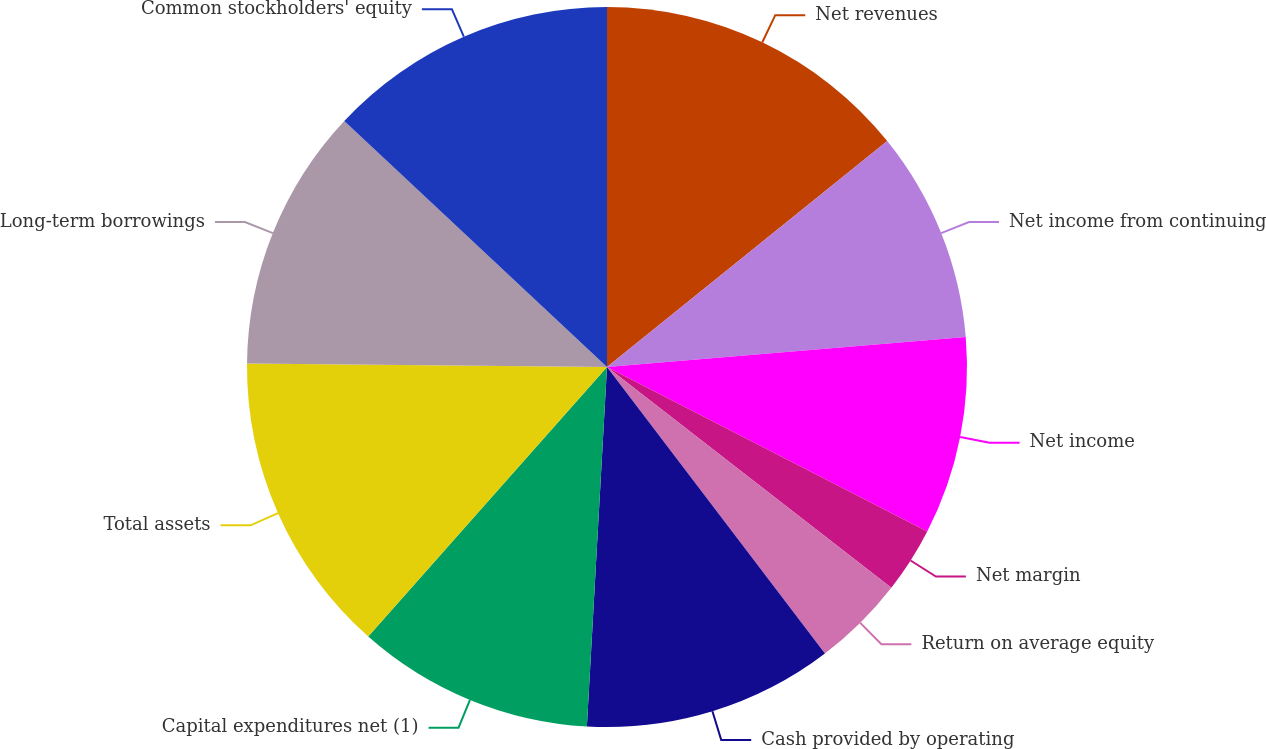Convert chart. <chart><loc_0><loc_0><loc_500><loc_500><pie_chart><fcel>Net revenues<fcel>Net income from continuing<fcel>Net income<fcel>Net margin<fcel>Return on average equity<fcel>Cash provided by operating<fcel>Capital expenditures net (1)<fcel>Total assets<fcel>Long-term borrowings<fcel>Common stockholders' equity<nl><fcel>14.2%<fcel>9.47%<fcel>8.88%<fcel>2.96%<fcel>4.14%<fcel>11.24%<fcel>10.65%<fcel>13.61%<fcel>11.83%<fcel>13.02%<nl></chart> 